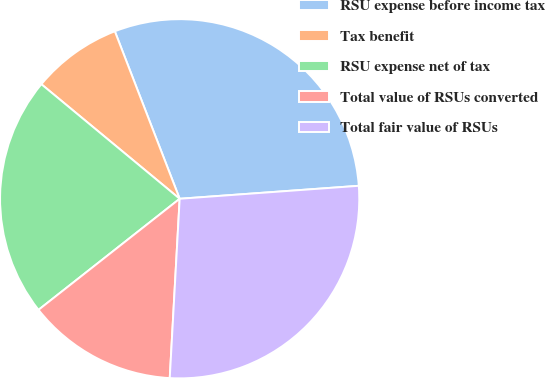Convert chart to OTSL. <chart><loc_0><loc_0><loc_500><loc_500><pie_chart><fcel>RSU expense before income tax<fcel>Tax benefit<fcel>RSU expense net of tax<fcel>Total value of RSUs converted<fcel>Total fair value of RSUs<nl><fcel>29.73%<fcel>8.11%<fcel>21.62%<fcel>13.51%<fcel>27.03%<nl></chart> 